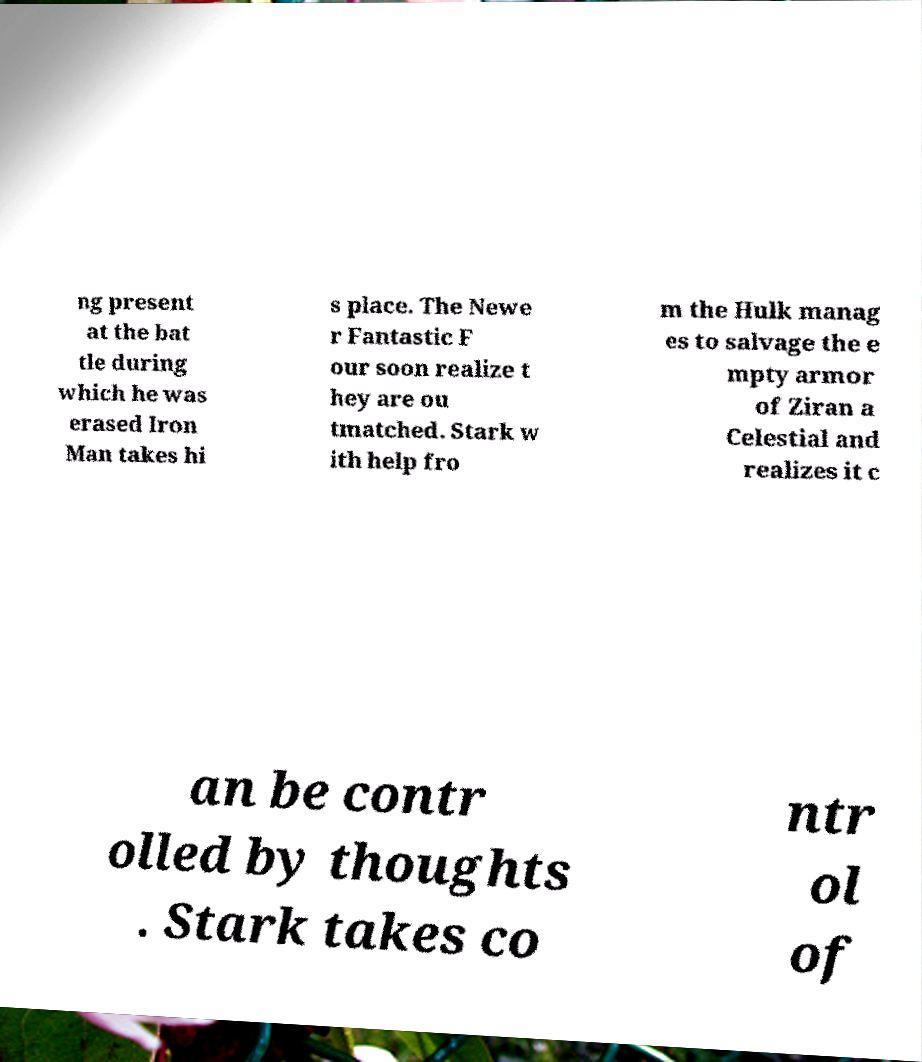Could you assist in decoding the text presented in this image and type it out clearly? ng present at the bat tle during which he was erased Iron Man takes hi s place. The Newe r Fantastic F our soon realize t hey are ou tmatched. Stark w ith help fro m the Hulk manag es to salvage the e mpty armor of Ziran a Celestial and realizes it c an be contr olled by thoughts . Stark takes co ntr ol of 